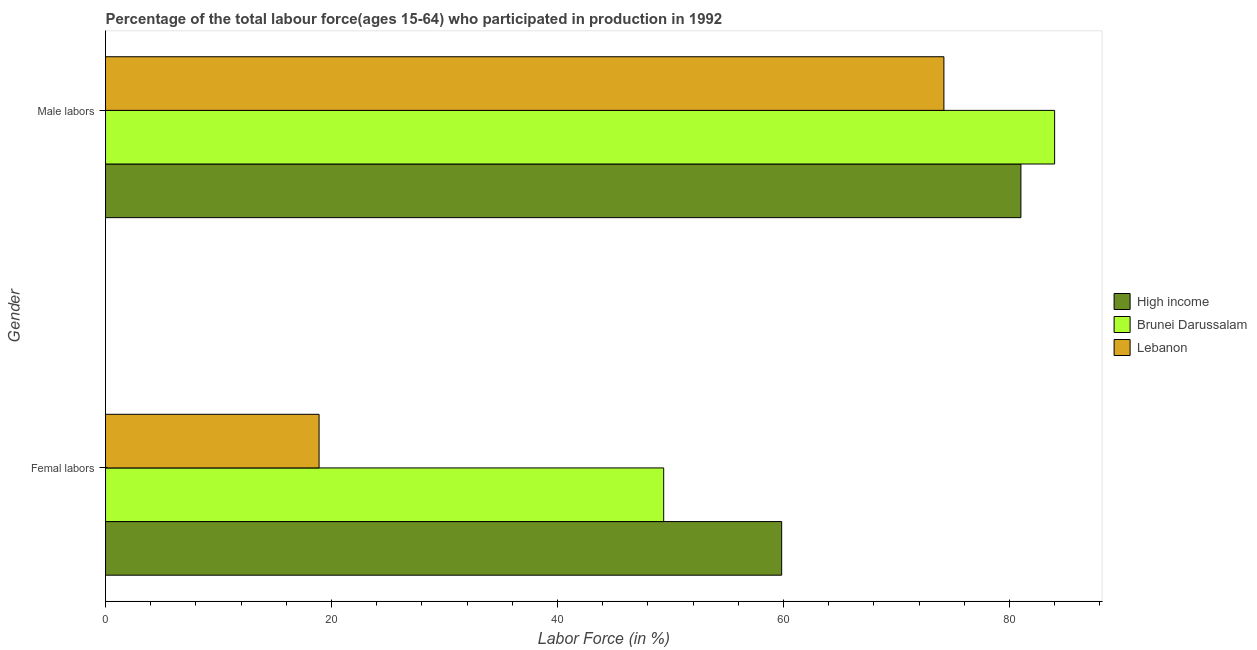How many different coloured bars are there?
Make the answer very short. 3. Are the number of bars on each tick of the Y-axis equal?
Provide a succinct answer. Yes. What is the label of the 2nd group of bars from the top?
Ensure brevity in your answer.  Femal labors. What is the percentage of female labor force in Brunei Darussalam?
Your response must be concise. 49.4. Across all countries, what is the minimum percentage of female labor force?
Offer a terse response. 18.9. In which country was the percentage of male labour force maximum?
Ensure brevity in your answer.  Brunei Darussalam. In which country was the percentage of female labor force minimum?
Your answer should be compact. Lebanon. What is the total percentage of female labor force in the graph?
Provide a short and direct response. 128.14. What is the difference between the percentage of male labour force in High income and that in Lebanon?
Keep it short and to the point. 6.82. What is the difference between the percentage of female labor force in High income and the percentage of male labour force in Lebanon?
Ensure brevity in your answer.  -14.36. What is the average percentage of female labor force per country?
Give a very brief answer. 42.71. What is the difference between the percentage of male labour force and percentage of female labor force in High income?
Your answer should be very brief. 21.17. What is the ratio of the percentage of female labor force in High income to that in Brunei Darussalam?
Give a very brief answer. 1.21. Is the percentage of female labor force in Lebanon less than that in Brunei Darussalam?
Your answer should be compact. Yes. What does the 3rd bar from the top in Femal labors represents?
Ensure brevity in your answer.  High income. What does the 3rd bar from the bottom in Femal labors represents?
Your answer should be very brief. Lebanon. Are all the bars in the graph horizontal?
Your response must be concise. Yes. How many countries are there in the graph?
Give a very brief answer. 3. What is the difference between two consecutive major ticks on the X-axis?
Keep it short and to the point. 20. Are the values on the major ticks of X-axis written in scientific E-notation?
Ensure brevity in your answer.  No. How are the legend labels stacked?
Make the answer very short. Vertical. What is the title of the graph?
Keep it short and to the point. Percentage of the total labour force(ages 15-64) who participated in production in 1992. Does "Channel Islands" appear as one of the legend labels in the graph?
Provide a succinct answer. No. What is the label or title of the X-axis?
Your answer should be compact. Labor Force (in %). What is the Labor Force (in %) in High income in Femal labors?
Keep it short and to the point. 59.84. What is the Labor Force (in %) of Brunei Darussalam in Femal labors?
Provide a succinct answer. 49.4. What is the Labor Force (in %) in Lebanon in Femal labors?
Ensure brevity in your answer.  18.9. What is the Labor Force (in %) in High income in Male labors?
Your answer should be very brief. 81.02. What is the Labor Force (in %) of Lebanon in Male labors?
Give a very brief answer. 74.2. Across all Gender, what is the maximum Labor Force (in %) of High income?
Ensure brevity in your answer.  81.02. Across all Gender, what is the maximum Labor Force (in %) of Brunei Darussalam?
Provide a succinct answer. 84. Across all Gender, what is the maximum Labor Force (in %) in Lebanon?
Offer a terse response. 74.2. Across all Gender, what is the minimum Labor Force (in %) in High income?
Provide a short and direct response. 59.84. Across all Gender, what is the minimum Labor Force (in %) in Brunei Darussalam?
Make the answer very short. 49.4. Across all Gender, what is the minimum Labor Force (in %) in Lebanon?
Keep it short and to the point. 18.9. What is the total Labor Force (in %) of High income in the graph?
Keep it short and to the point. 140.86. What is the total Labor Force (in %) in Brunei Darussalam in the graph?
Your answer should be very brief. 133.4. What is the total Labor Force (in %) in Lebanon in the graph?
Keep it short and to the point. 93.1. What is the difference between the Labor Force (in %) of High income in Femal labors and that in Male labors?
Offer a very short reply. -21.17. What is the difference between the Labor Force (in %) of Brunei Darussalam in Femal labors and that in Male labors?
Keep it short and to the point. -34.6. What is the difference between the Labor Force (in %) of Lebanon in Femal labors and that in Male labors?
Offer a very short reply. -55.3. What is the difference between the Labor Force (in %) of High income in Femal labors and the Labor Force (in %) of Brunei Darussalam in Male labors?
Provide a short and direct response. -24.16. What is the difference between the Labor Force (in %) of High income in Femal labors and the Labor Force (in %) of Lebanon in Male labors?
Provide a succinct answer. -14.36. What is the difference between the Labor Force (in %) of Brunei Darussalam in Femal labors and the Labor Force (in %) of Lebanon in Male labors?
Offer a very short reply. -24.8. What is the average Labor Force (in %) in High income per Gender?
Keep it short and to the point. 70.43. What is the average Labor Force (in %) in Brunei Darussalam per Gender?
Keep it short and to the point. 66.7. What is the average Labor Force (in %) of Lebanon per Gender?
Keep it short and to the point. 46.55. What is the difference between the Labor Force (in %) of High income and Labor Force (in %) of Brunei Darussalam in Femal labors?
Your answer should be very brief. 10.44. What is the difference between the Labor Force (in %) of High income and Labor Force (in %) of Lebanon in Femal labors?
Keep it short and to the point. 40.94. What is the difference between the Labor Force (in %) in Brunei Darussalam and Labor Force (in %) in Lebanon in Femal labors?
Ensure brevity in your answer.  30.5. What is the difference between the Labor Force (in %) in High income and Labor Force (in %) in Brunei Darussalam in Male labors?
Offer a very short reply. -2.98. What is the difference between the Labor Force (in %) in High income and Labor Force (in %) in Lebanon in Male labors?
Make the answer very short. 6.82. What is the difference between the Labor Force (in %) of Brunei Darussalam and Labor Force (in %) of Lebanon in Male labors?
Make the answer very short. 9.8. What is the ratio of the Labor Force (in %) in High income in Femal labors to that in Male labors?
Provide a succinct answer. 0.74. What is the ratio of the Labor Force (in %) in Brunei Darussalam in Femal labors to that in Male labors?
Give a very brief answer. 0.59. What is the ratio of the Labor Force (in %) of Lebanon in Femal labors to that in Male labors?
Provide a succinct answer. 0.25. What is the difference between the highest and the second highest Labor Force (in %) in High income?
Give a very brief answer. 21.17. What is the difference between the highest and the second highest Labor Force (in %) in Brunei Darussalam?
Your response must be concise. 34.6. What is the difference between the highest and the second highest Labor Force (in %) of Lebanon?
Provide a succinct answer. 55.3. What is the difference between the highest and the lowest Labor Force (in %) in High income?
Your answer should be very brief. 21.17. What is the difference between the highest and the lowest Labor Force (in %) of Brunei Darussalam?
Offer a very short reply. 34.6. What is the difference between the highest and the lowest Labor Force (in %) in Lebanon?
Provide a short and direct response. 55.3. 